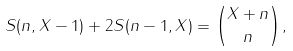<formula> <loc_0><loc_0><loc_500><loc_500>S ( n , X - 1 ) + 2 S ( n - 1 , X ) = { X + n \choose n } ,</formula> 